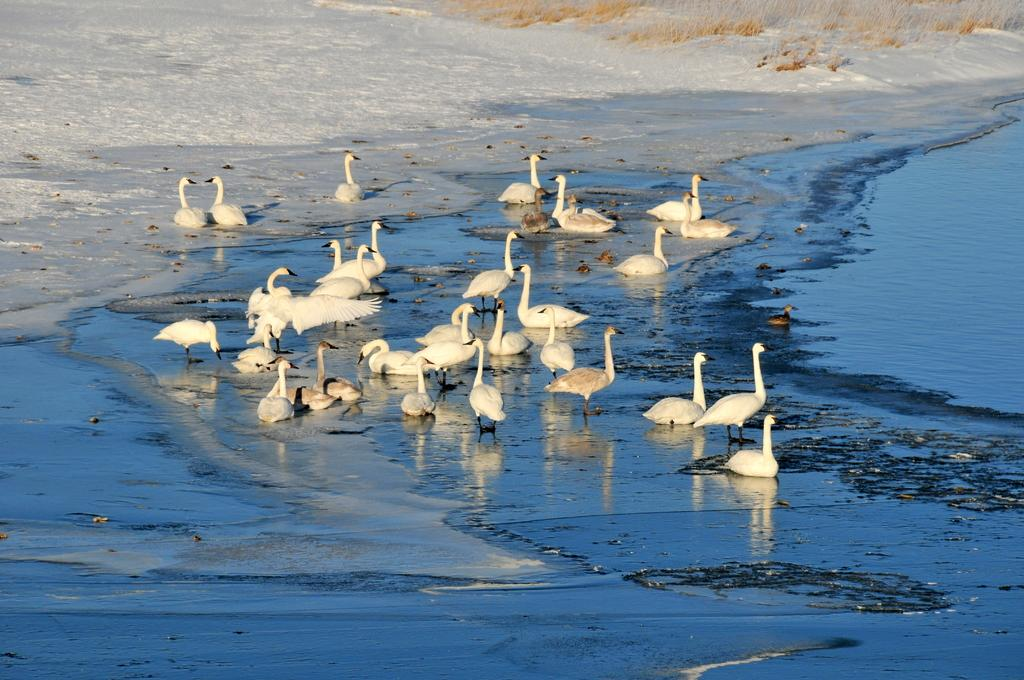What animals are present in the image? There are swans in the image. What is located on the right side of the image? There is water on the right side of the image. What type of weather is suggested by the presence of snow in the image? The presence of snow in the background of the image suggests cold weather. What type of verse can be heard being recited in the image? There is no indication in the image that any verse is being recited, so it cannot be determined from the picture. 